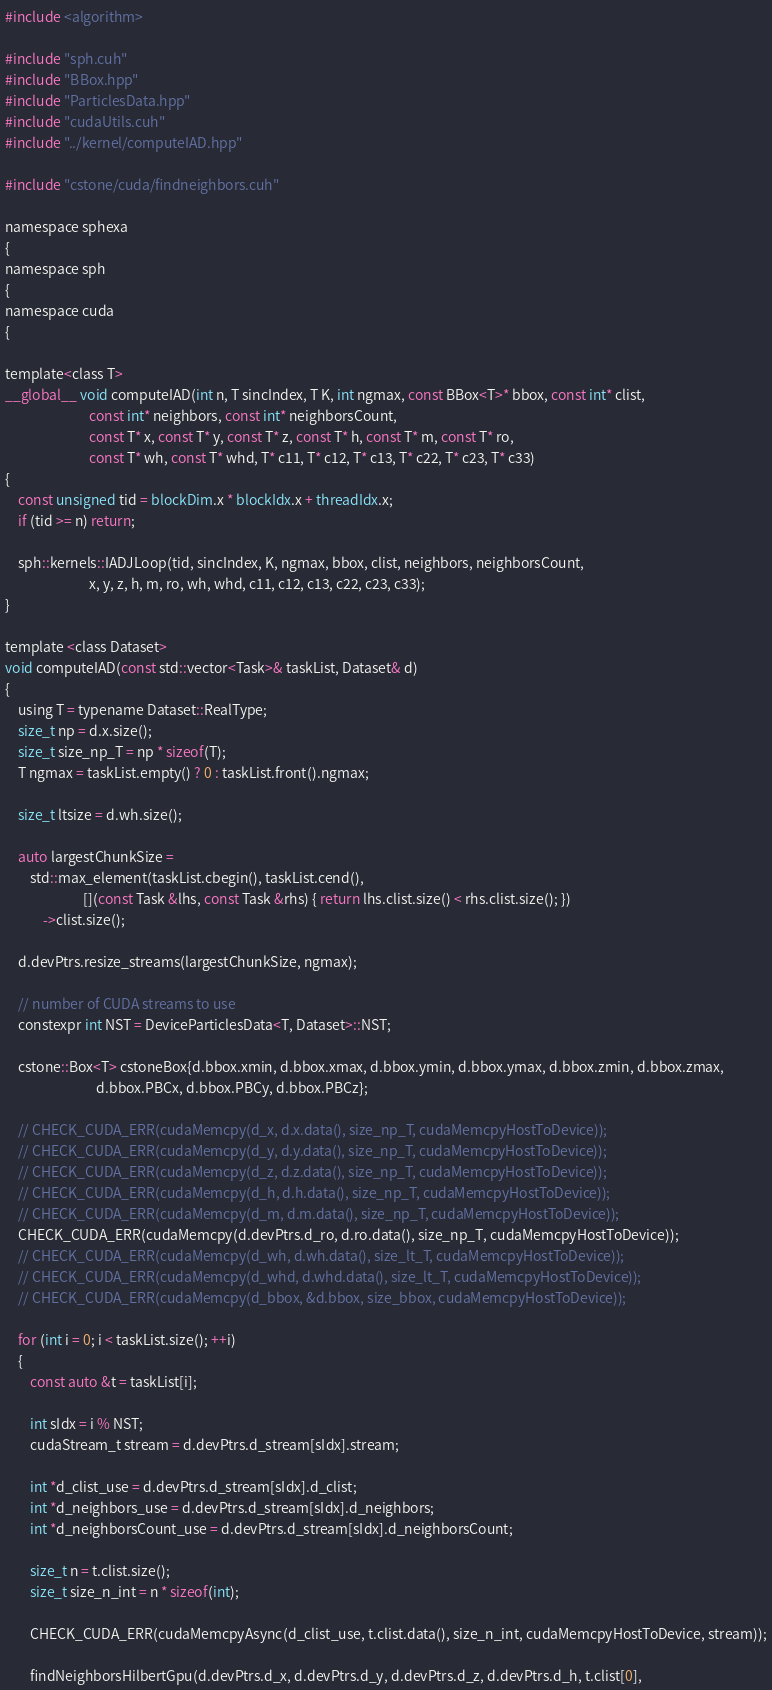<code> <loc_0><loc_0><loc_500><loc_500><_Cuda_>#include <algorithm>

#include "sph.cuh"
#include "BBox.hpp"
#include "ParticlesData.hpp"
#include "cudaUtils.cuh"
#include "../kernel/computeIAD.hpp"

#include "cstone/cuda/findneighbors.cuh"

namespace sphexa
{
namespace sph
{
namespace cuda
{

template<class T>
__global__ void computeIAD(int n, T sincIndex, T K, int ngmax, const BBox<T>* bbox, const int* clist,
                           const int* neighbors, const int* neighborsCount,
                           const T* x, const T* y, const T* z, const T* h, const T* m, const T* ro,
                           const T* wh, const T* whd, T* c11, T* c12, T* c13, T* c22, T* c23, T* c33)
{
    const unsigned tid = blockDim.x * blockIdx.x + threadIdx.x;
    if (tid >= n) return;

    sph::kernels::IADJLoop(tid, sincIndex, K, ngmax, bbox, clist, neighbors, neighborsCount,
                           x, y, z, h, m, ro, wh, whd, c11, c12, c13, c22, c23, c33);
}

template <class Dataset>
void computeIAD(const std::vector<Task>& taskList, Dataset& d)
{
    using T = typename Dataset::RealType;
    size_t np = d.x.size();
    size_t size_np_T = np * sizeof(T);
    T ngmax = taskList.empty() ? 0 : taskList.front().ngmax;

    size_t ltsize = d.wh.size();

    auto largestChunkSize =
        std::max_element(taskList.cbegin(), taskList.cend(),
                         [](const Task &lhs, const Task &rhs) { return lhs.clist.size() < rhs.clist.size(); })
            ->clist.size();

    d.devPtrs.resize_streams(largestChunkSize, ngmax);

    // number of CUDA streams to use
    constexpr int NST = DeviceParticlesData<T, Dataset>::NST;

    cstone::Box<T> cstoneBox{d.bbox.xmin, d.bbox.xmax, d.bbox.ymin, d.bbox.ymax, d.bbox.zmin, d.bbox.zmax,
                             d.bbox.PBCx, d.bbox.PBCy, d.bbox.PBCz};

    // CHECK_CUDA_ERR(cudaMemcpy(d_x, d.x.data(), size_np_T, cudaMemcpyHostToDevice));
    // CHECK_CUDA_ERR(cudaMemcpy(d_y, d.y.data(), size_np_T, cudaMemcpyHostToDevice));
    // CHECK_CUDA_ERR(cudaMemcpy(d_z, d.z.data(), size_np_T, cudaMemcpyHostToDevice));
    // CHECK_CUDA_ERR(cudaMemcpy(d_h, d.h.data(), size_np_T, cudaMemcpyHostToDevice));
    // CHECK_CUDA_ERR(cudaMemcpy(d_m, d.m.data(), size_np_T, cudaMemcpyHostToDevice));
    CHECK_CUDA_ERR(cudaMemcpy(d.devPtrs.d_ro, d.ro.data(), size_np_T, cudaMemcpyHostToDevice));
    // CHECK_CUDA_ERR(cudaMemcpy(d_wh, d.wh.data(), size_lt_T, cudaMemcpyHostToDevice));
    // CHECK_CUDA_ERR(cudaMemcpy(d_whd, d.whd.data(), size_lt_T, cudaMemcpyHostToDevice));
    // CHECK_CUDA_ERR(cudaMemcpy(d_bbox, &d.bbox, size_bbox, cudaMemcpyHostToDevice));

    for (int i = 0; i < taskList.size(); ++i)
    {
        const auto &t = taskList[i];

        int sIdx = i % NST;
        cudaStream_t stream = d.devPtrs.d_stream[sIdx].stream;

        int *d_clist_use = d.devPtrs.d_stream[sIdx].d_clist;
        int *d_neighbors_use = d.devPtrs.d_stream[sIdx].d_neighbors;
        int *d_neighborsCount_use = d.devPtrs.d_stream[sIdx].d_neighborsCount;

        size_t n = t.clist.size();
        size_t size_n_int = n * sizeof(int);

        CHECK_CUDA_ERR(cudaMemcpyAsync(d_clist_use, t.clist.data(), size_n_int, cudaMemcpyHostToDevice, stream));

        findNeighborsHilbertGpu(d.devPtrs.d_x, d.devPtrs.d_y, d.devPtrs.d_z, d.devPtrs.d_h, t.clist[0],</code> 